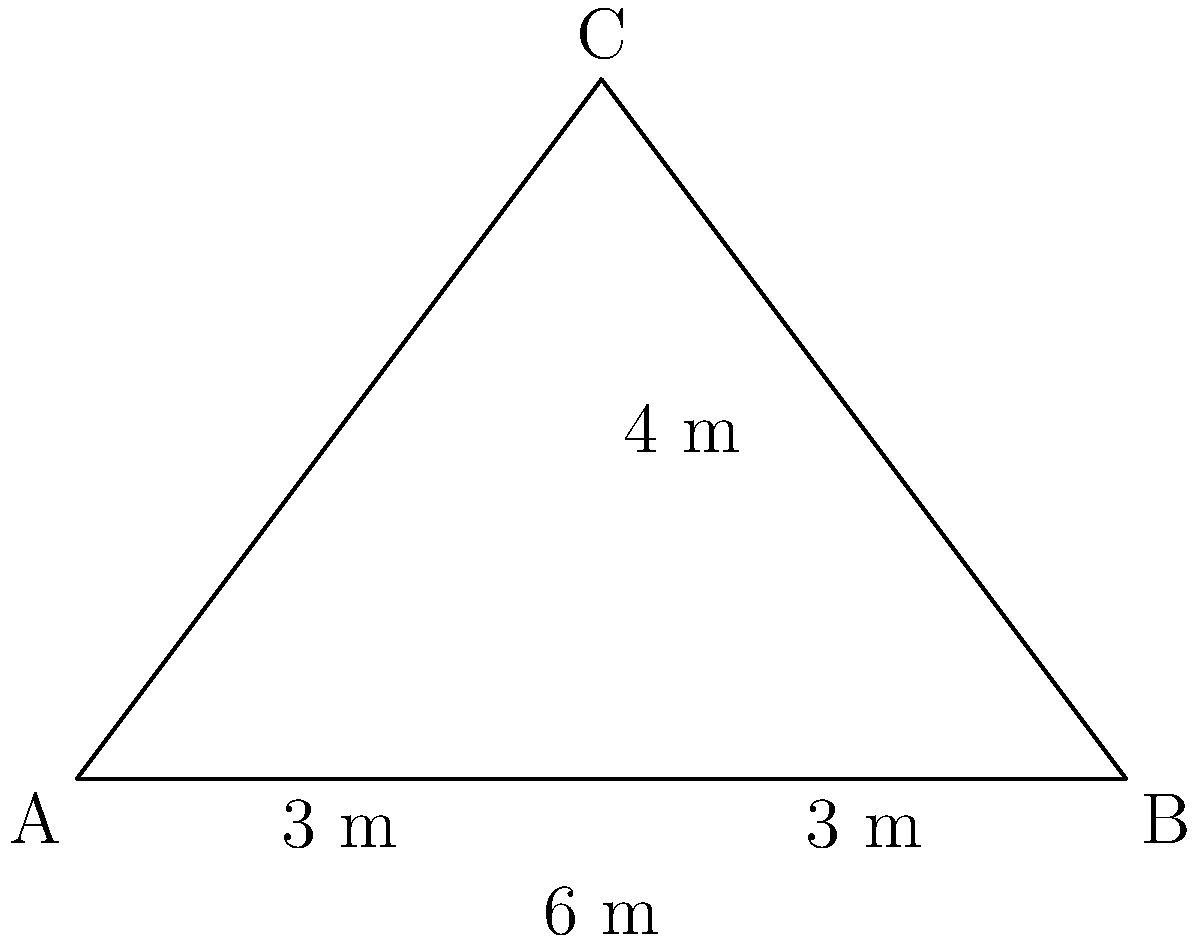For the upcoming Spring Fest at Walsh University, you're tasked with creating a triangular banner. The base of the banner needs to be 6 meters wide to span the entrance of the student center. If the banner is designed as an isosceles triangle with a height of 4 meters, what is the length of each of the two equal sides of the banner? Let's approach this step-by-step:

1) We have an isosceles triangle with base 6 m and height 4 m.

2) The base is divided into two equal parts of 3 m each by the height.

3) We can use the Pythagorean theorem to find the length of one of the equal sides. Let's call this length $x$.

4) In the right triangle formed by half the base, the height, and one of the equal sides:
   $$(3 \text{ m})^2 + (4 \text{ m})^2 = x^2$$

5) Simplifying:
   $$9 \text{ m}^2 + 16 \text{ m}^2 = x^2$$
   $$25 \text{ m}^2 = x^2$$

6) Taking the square root of both sides:
   $$x = \sqrt{25 \text{ m}^2} = 5 \text{ m}$$

Therefore, each of the two equal sides of the banner is 5 meters long.
Answer: 5 m 